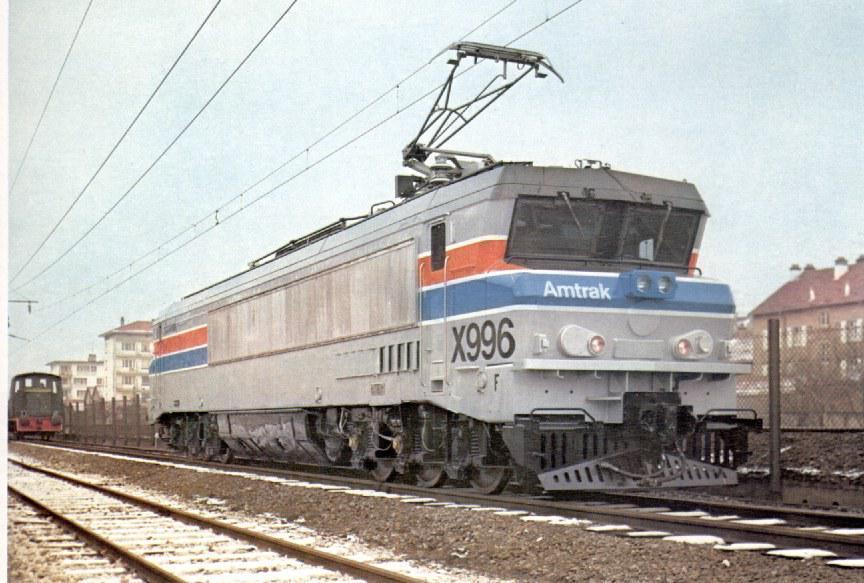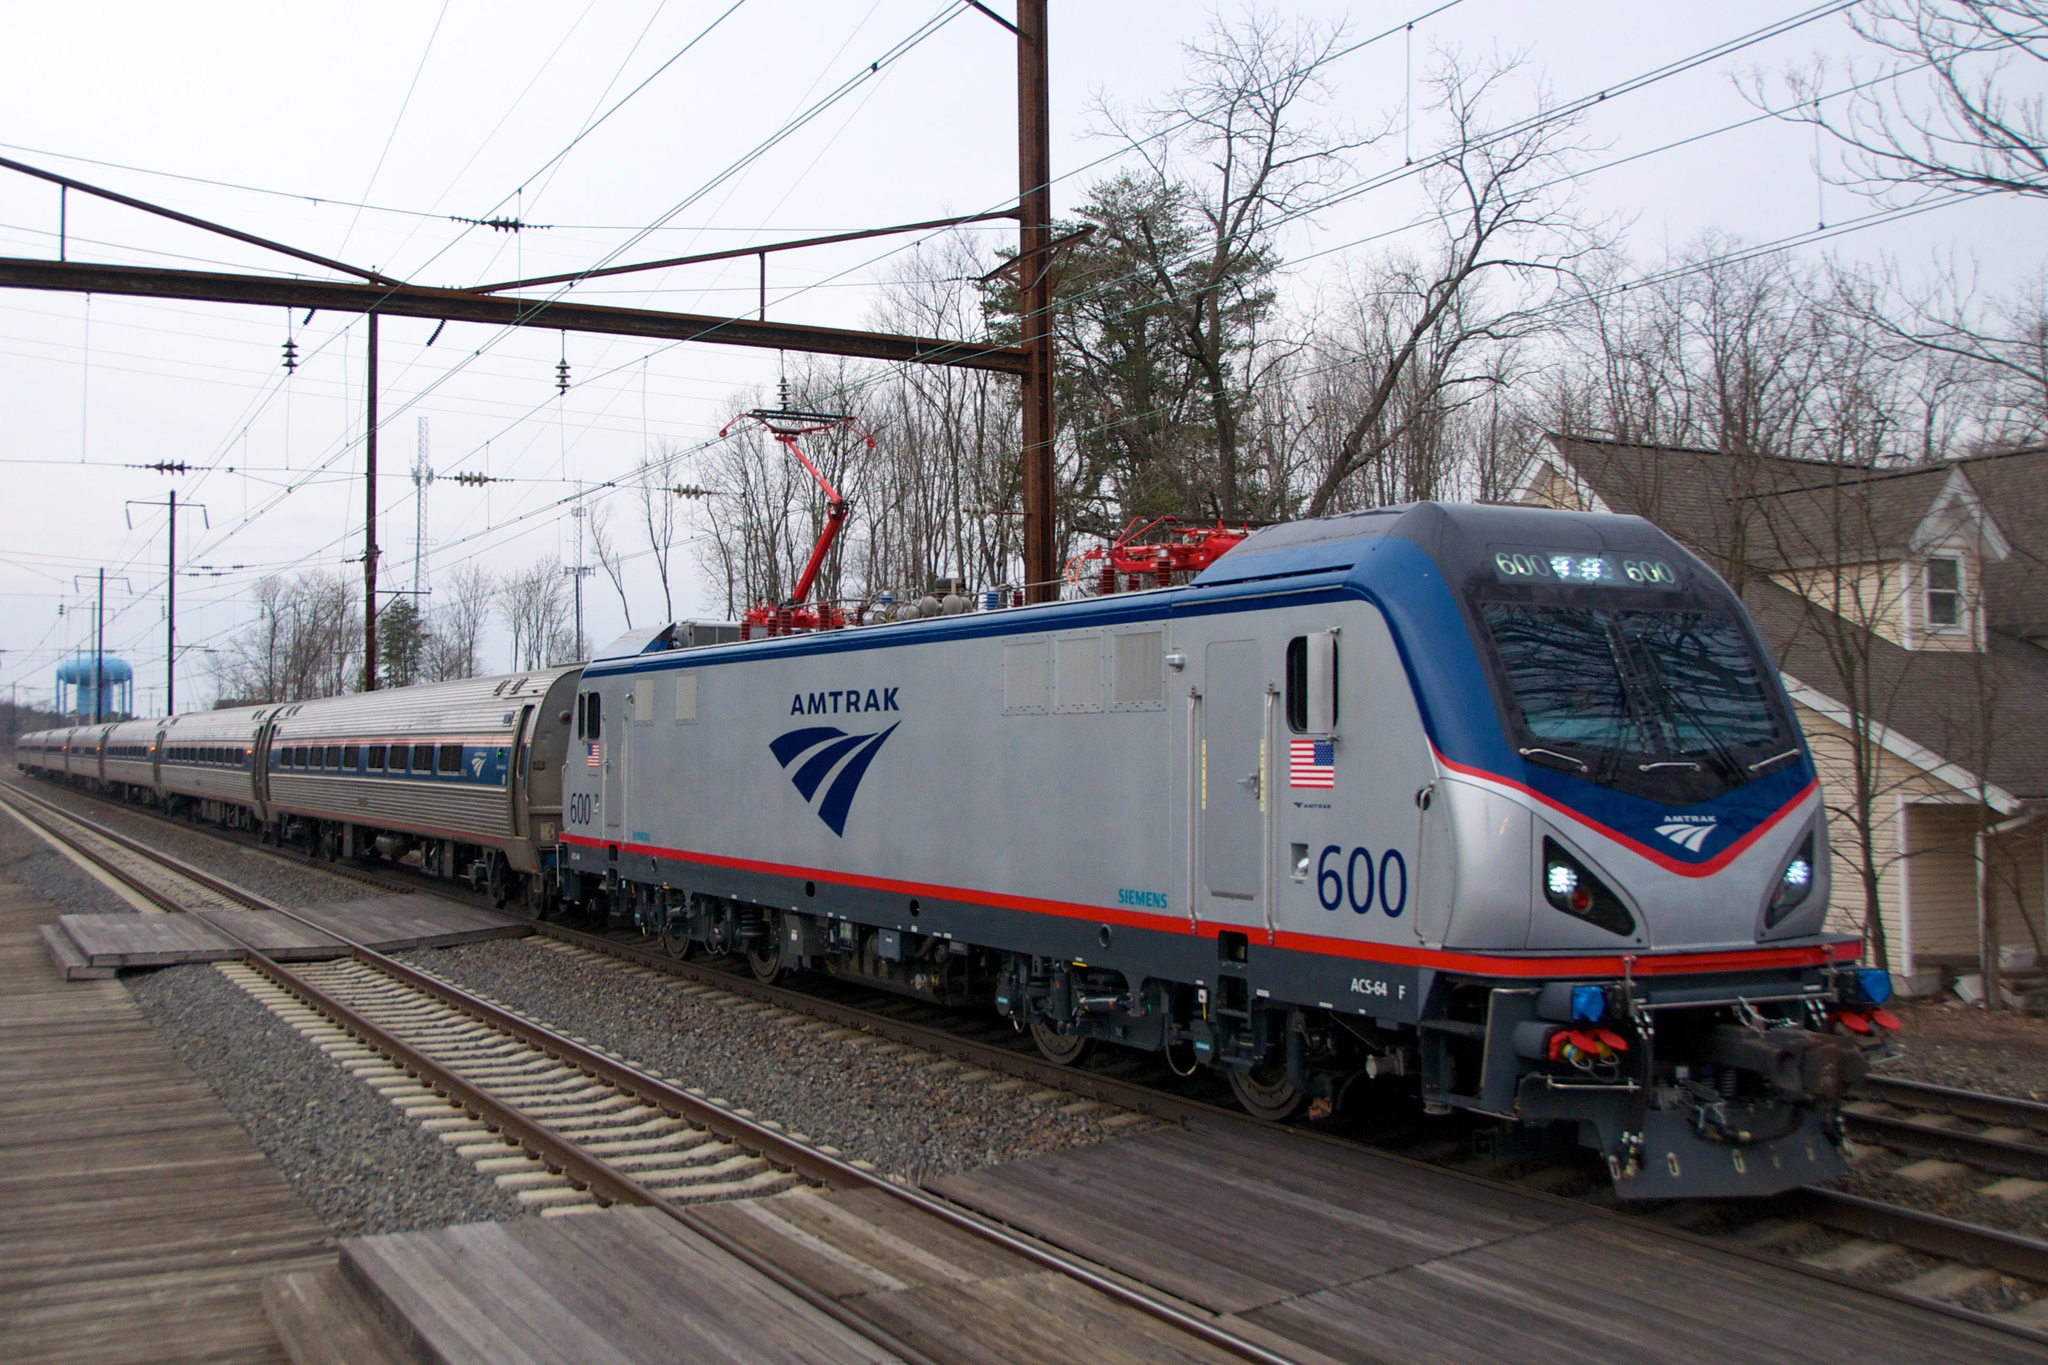The first image is the image on the left, the second image is the image on the right. Examine the images to the left and right. Is the description "At least one train has a flat front and blue and red stripes outlined in white running the length of the sides." accurate? Answer yes or no. No. The first image is the image on the left, the second image is the image on the right. Assess this claim about the two images: "Each train is headed in the same direction.". Correct or not? Answer yes or no. Yes. 